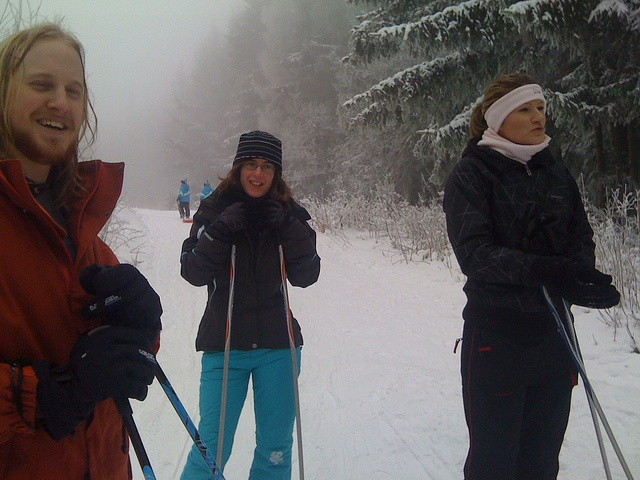Describe the objects in this image and their specific colors. I can see people in darkgray, black, maroon, and gray tones, people in darkgray, black, gray, and maroon tones, people in darkgray, black, teal, and gray tones, people in darkgray, gray, and blue tones, and people in darkgray, gray, teal, and blue tones in this image. 